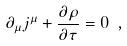<formula> <loc_0><loc_0><loc_500><loc_500>\partial _ { \mu } j ^ { \mu } + \frac { \partial \rho } { \partial \tau } = 0 \ ,</formula> 